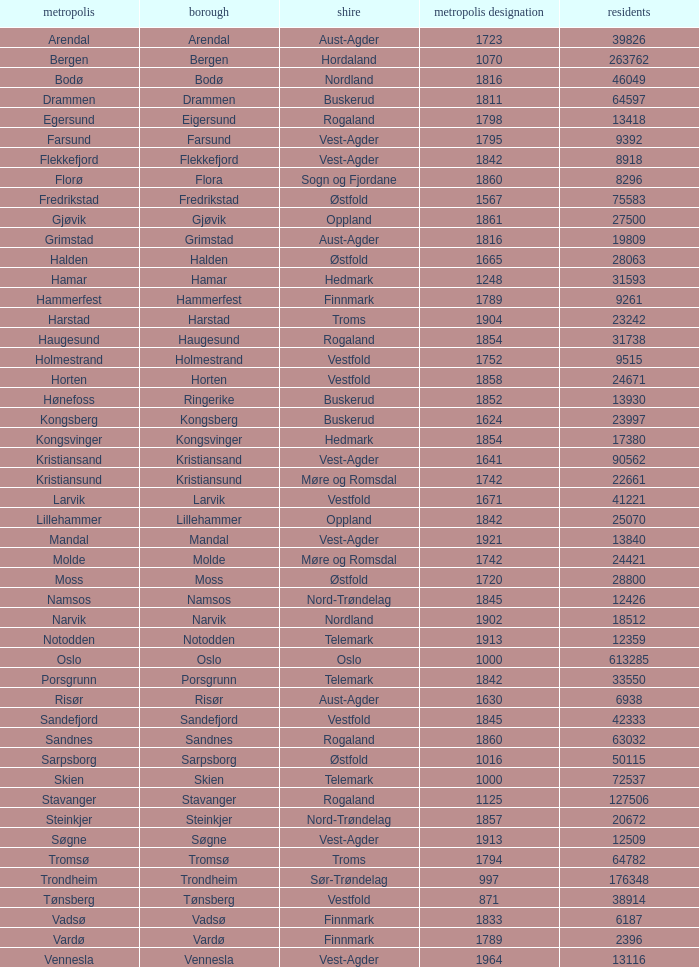In which county is the city/town of Halden located? Østfold. 